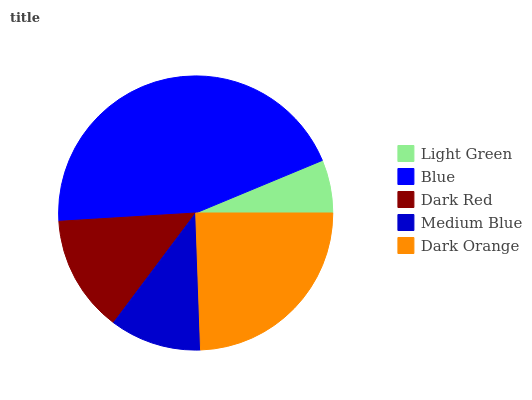Is Light Green the minimum?
Answer yes or no. Yes. Is Blue the maximum?
Answer yes or no. Yes. Is Dark Red the minimum?
Answer yes or no. No. Is Dark Red the maximum?
Answer yes or no. No. Is Blue greater than Dark Red?
Answer yes or no. Yes. Is Dark Red less than Blue?
Answer yes or no. Yes. Is Dark Red greater than Blue?
Answer yes or no. No. Is Blue less than Dark Red?
Answer yes or no. No. Is Dark Red the high median?
Answer yes or no. Yes. Is Dark Red the low median?
Answer yes or no. Yes. Is Dark Orange the high median?
Answer yes or no. No. Is Dark Orange the low median?
Answer yes or no. No. 